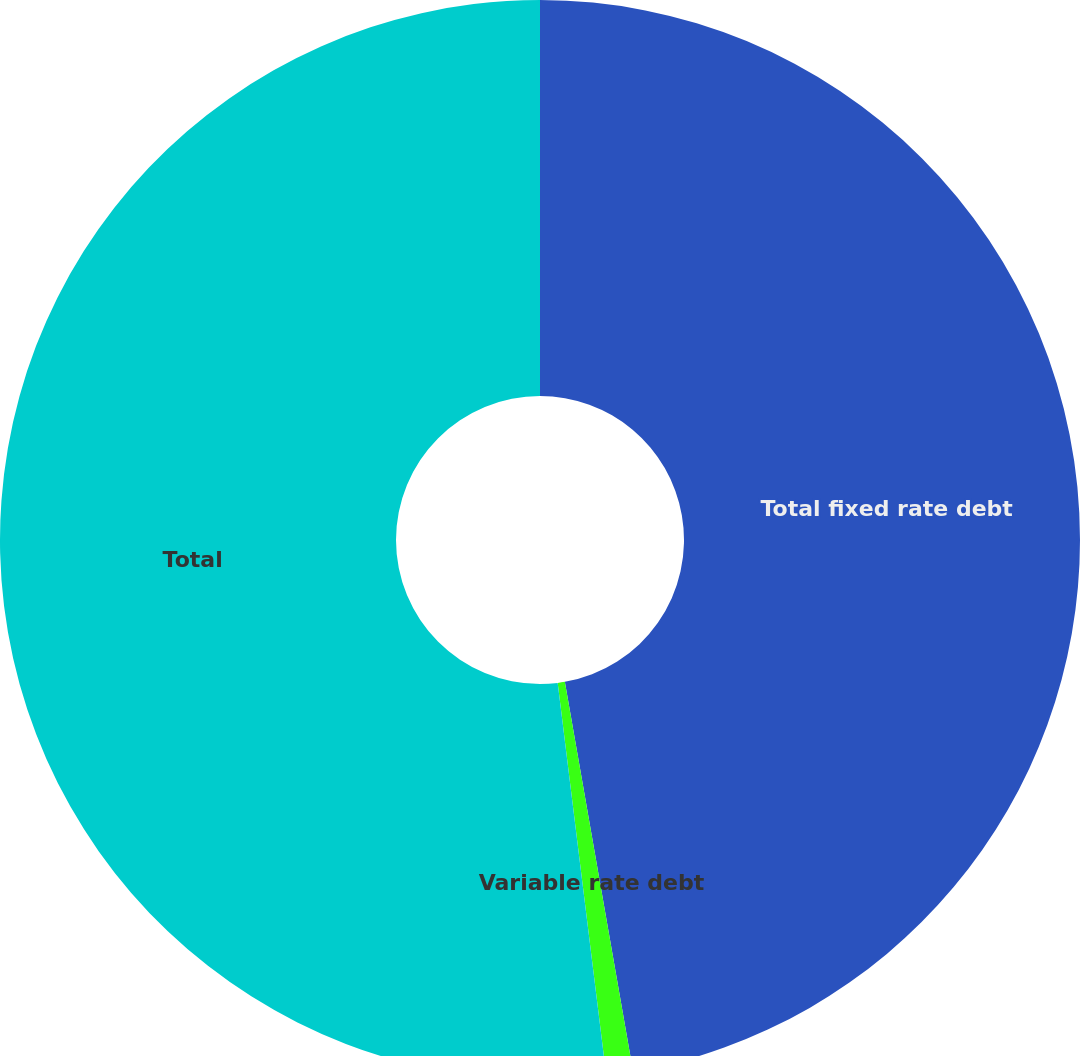<chart> <loc_0><loc_0><loc_500><loc_500><pie_chart><fcel>Total fixed rate debt<fcel>Variable rate debt<fcel>Total<nl><fcel>47.24%<fcel>0.8%<fcel>51.96%<nl></chart> 